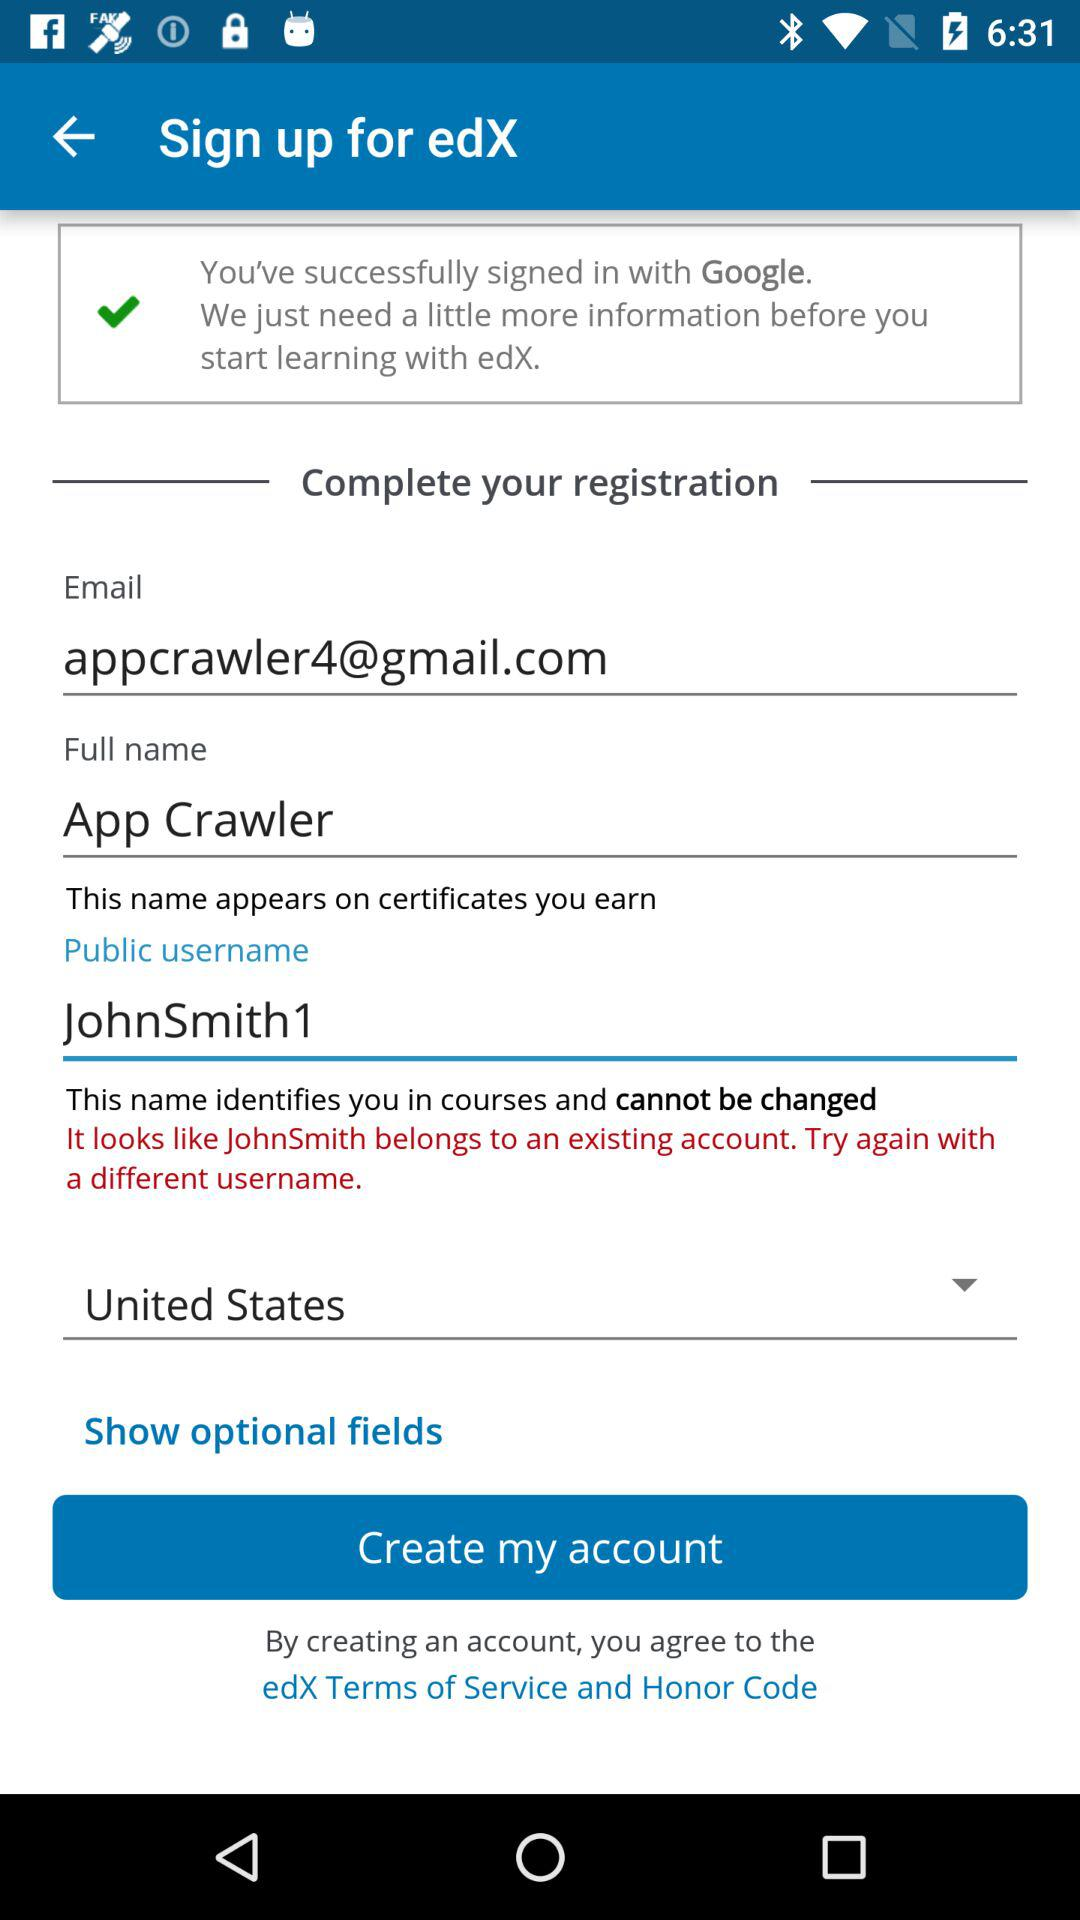What is the public username? The public username is "JohnSmith1". 